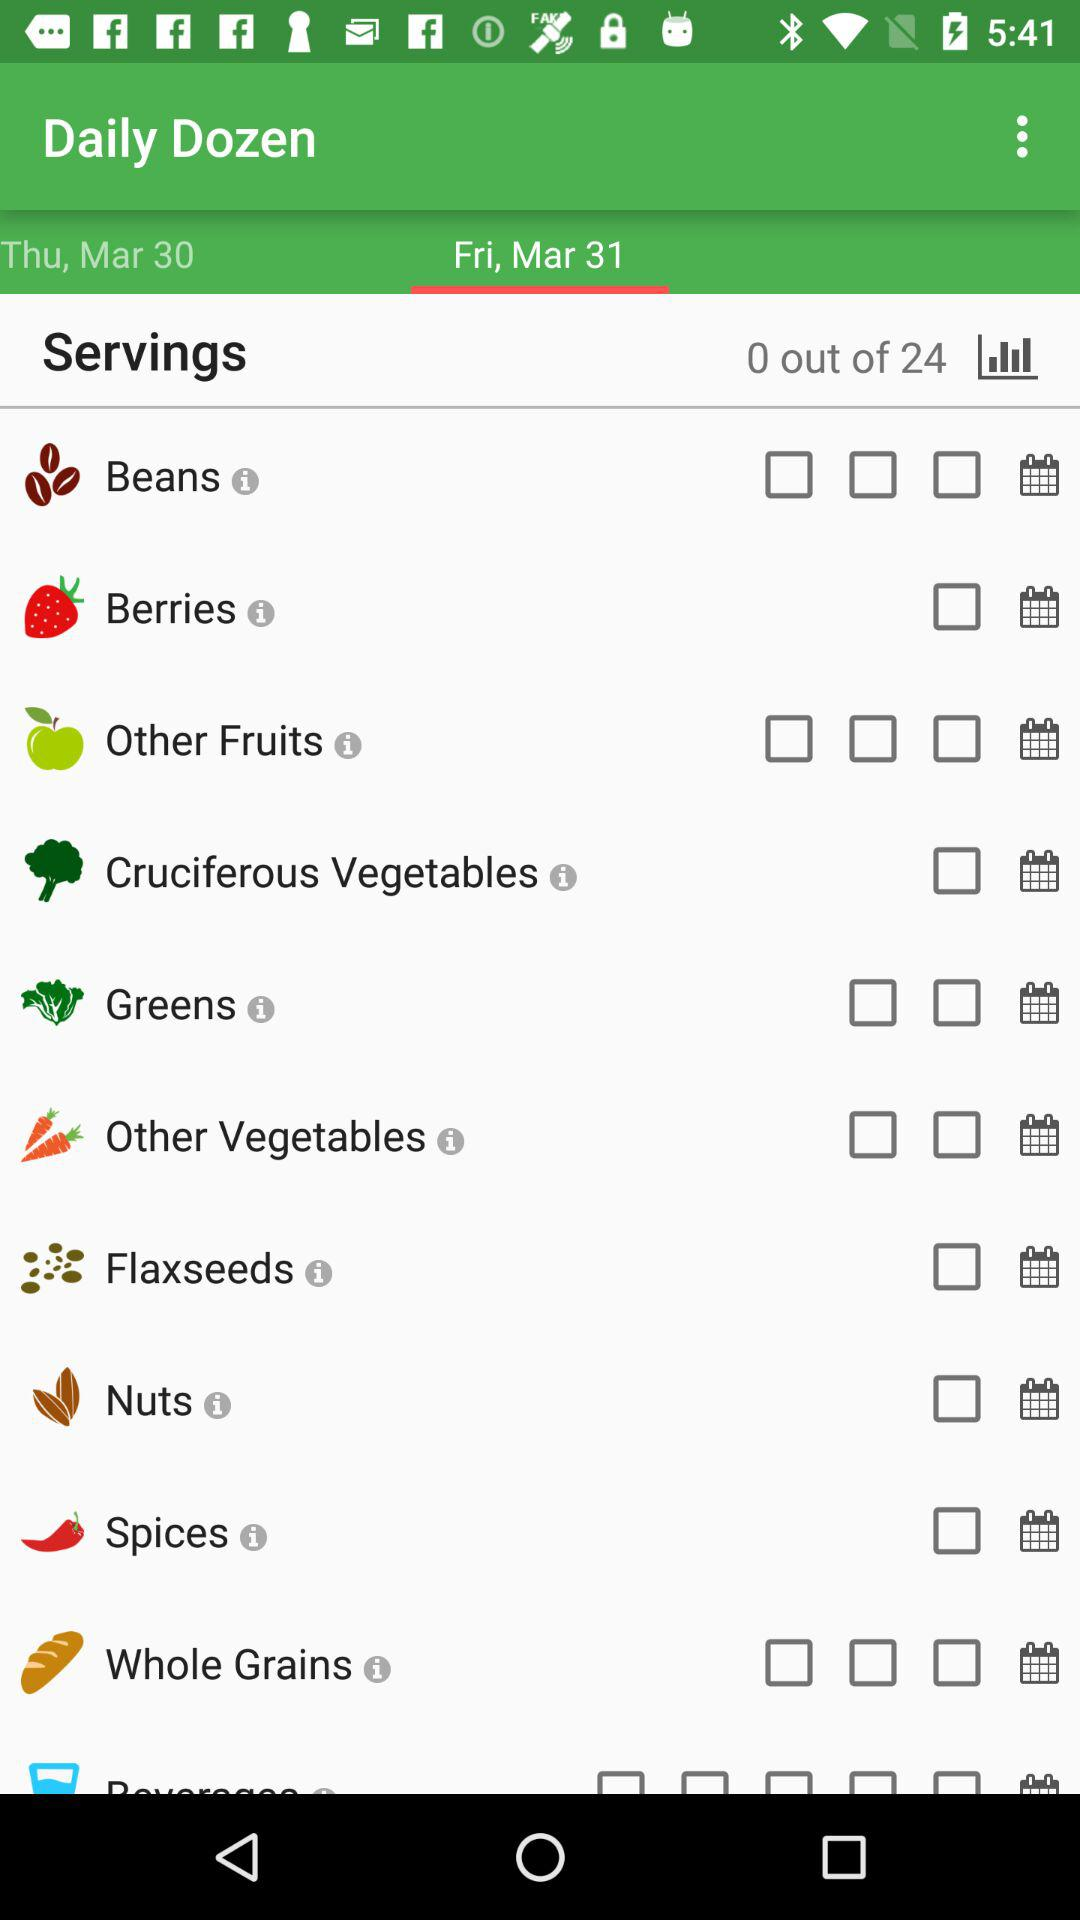How many servings in total are there? There are 24 servings in total. 